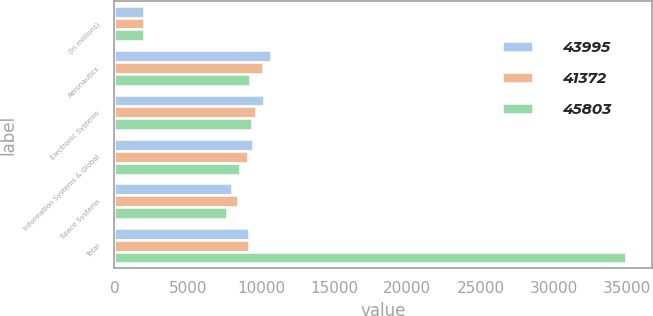<chart> <loc_0><loc_0><loc_500><loc_500><stacked_bar_chart><ecel><fcel>(In millions)<fcel>Aeronautics<fcel>Electronic Systems<fcel>Information Systems & Global<fcel>Space Systems<fcel>Total<nl><fcel>43995<fcel>2010<fcel>10720<fcel>10242<fcel>9437<fcel>7995<fcel>9198<nl><fcel>41372<fcel>2009<fcel>10151<fcel>9699<fcel>9128<fcel>8405<fcel>9198<nl><fcel>45803<fcel>2008<fcel>9268<fcel>9405<fcel>8588<fcel>7685<fcel>34946<nl></chart> 